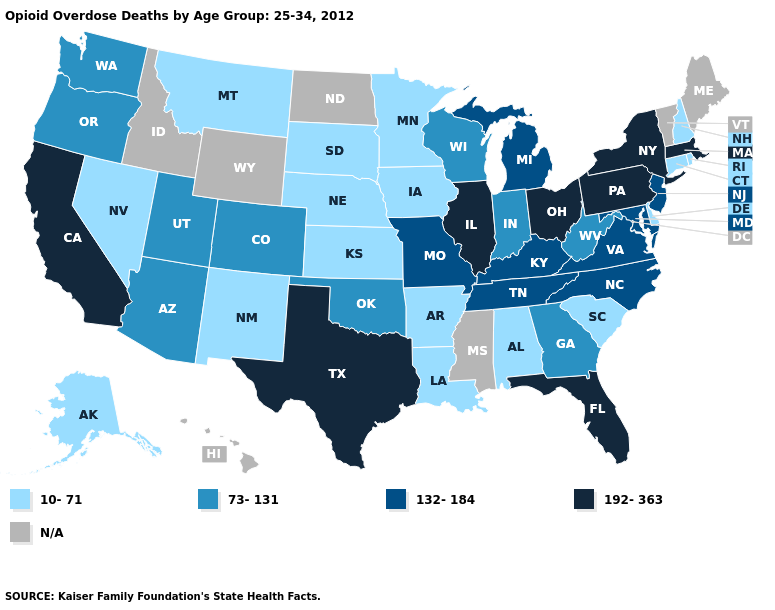Among the states that border New Mexico , which have the lowest value?
Concise answer only. Arizona, Colorado, Oklahoma, Utah. What is the value of South Dakota?
Quick response, please. 10-71. Name the states that have a value in the range N/A?
Answer briefly. Hawaii, Idaho, Maine, Mississippi, North Dakota, Vermont, Wyoming. What is the value of Hawaii?
Quick response, please. N/A. What is the value of Colorado?
Be succinct. 73-131. Does the first symbol in the legend represent the smallest category?
Short answer required. Yes. Does the map have missing data?
Give a very brief answer. Yes. Is the legend a continuous bar?
Short answer required. No. What is the value of Alabama?
Answer briefly. 10-71. What is the lowest value in the USA?
Keep it brief. 10-71. Does Illinois have the lowest value in the MidWest?
Quick response, please. No. Does Ohio have the highest value in the USA?
Keep it brief. Yes. 